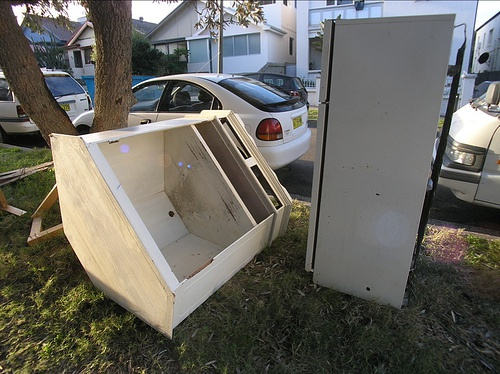Describe the objects in this image and their specific colors. I can see refrigerator in black and gray tones, car in black, darkgray, and gray tones, truck in black, gray, ivory, and darkgray tones, car in black, gray, and darkgray tones, and car in black, gray, and blue tones in this image. 